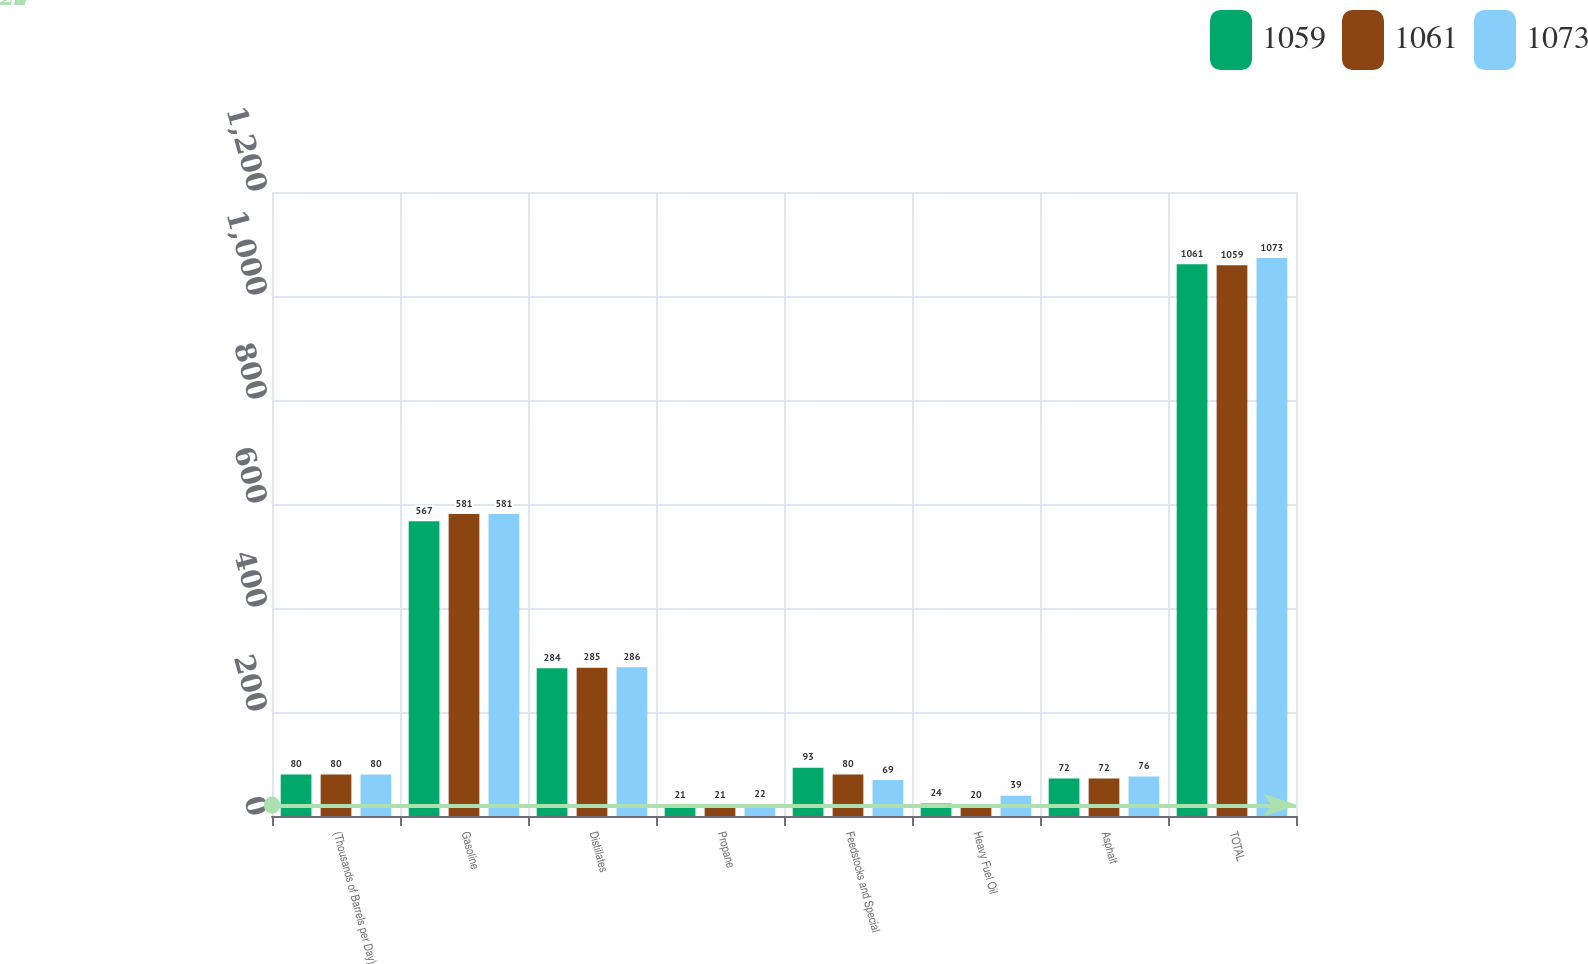Convert chart to OTSL. <chart><loc_0><loc_0><loc_500><loc_500><stacked_bar_chart><ecel><fcel>(Thousands of Barrels per Day)<fcel>Gasoline<fcel>Distillates<fcel>Propane<fcel>Feedstocks and Special<fcel>Heavy Fuel Oil<fcel>Asphalt<fcel>TOTAL<nl><fcel>1059<fcel>80<fcel>567<fcel>284<fcel>21<fcel>93<fcel>24<fcel>72<fcel>1061<nl><fcel>1061<fcel>80<fcel>581<fcel>285<fcel>21<fcel>80<fcel>20<fcel>72<fcel>1059<nl><fcel>1073<fcel>80<fcel>581<fcel>286<fcel>22<fcel>69<fcel>39<fcel>76<fcel>1073<nl></chart> 